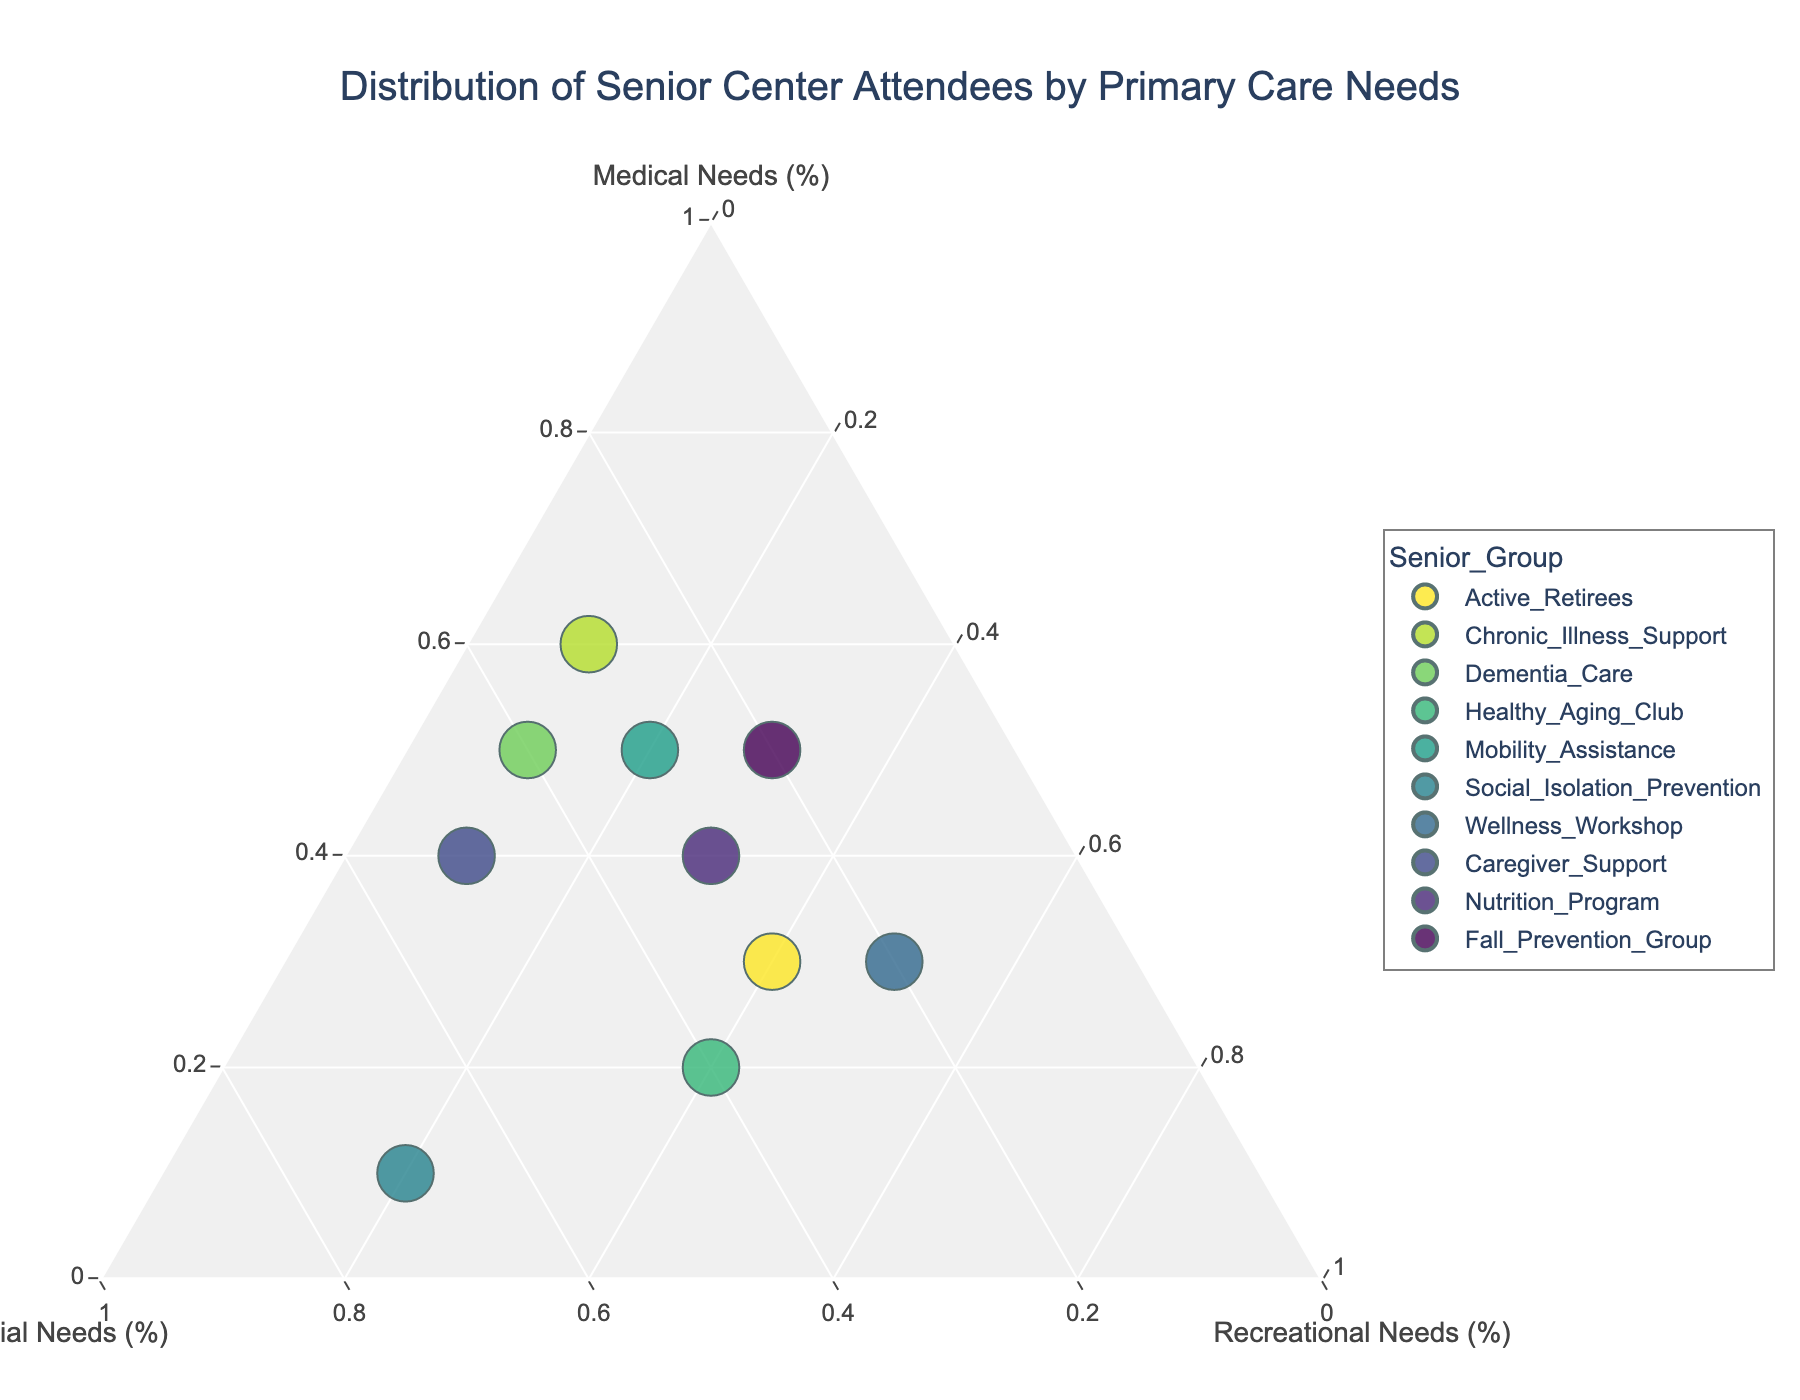What is the title of the ternary plot? The title is typically displayed at the top of the figure. Look for the main heading.
Answer: "Distribution of Senior Center Attendees by Primary Care Needs" How many senior groups are represented in the plot? Count the number of unique data points or groups labeled in the plot.
Answer: 10 Which group has the highest percentage for Recreational needs? Locate the data point farthest along the "Recreational" axis. This group will have the highest percentage in Recreational needs.
Answer: Wellness Workshop Which groups have a higher percentage of Medical needs than Social needs? Identify the data points where the Medical percentage is higher than the Social percentage.
Answer: Active Retirees, Chronic Illness Support, Dementia Care, Mobility Assistance, Fall Prevention Group, Wellness Workshop, Nutrition Program Across all the groups, which one has the lowest percentage of Social needs? Find the group closest to the Medical-Recreational side of the ternary plot, indicating the lowest Social needs.
Answer: Wellness Workshop What is the combined percentage of Medical and Recreational needs for the Chronic Illness Support group? Sum the Medical and Recreational percentages for the Chronic Illness Support group: 0.6 (Medical) + 0.1 (Recreational).
Answer: 70% Among the groups, which one equally divides attention between Medical, Social, and Recreational needs? Look for a data point around the center of the plot where the values of Medical, Social, and Recreational are equal or almost equal.
Answer: Active Retirees How does the Wellness Workshop group compare with the Dementia Care group in terms of Medical needs? Compare the Medical percentage of the Wellness Workshop (0.3) with that of Dementia Care (0.5).
Answer: Dementia Care has higher Medical needs Which group has the highest percentage of Social needs, and what is that percentage? Locate the group farthest along the "Social" axis. This group will have the highest percentage in Social needs.
Answer: Social Isolation Prevention, 70% 